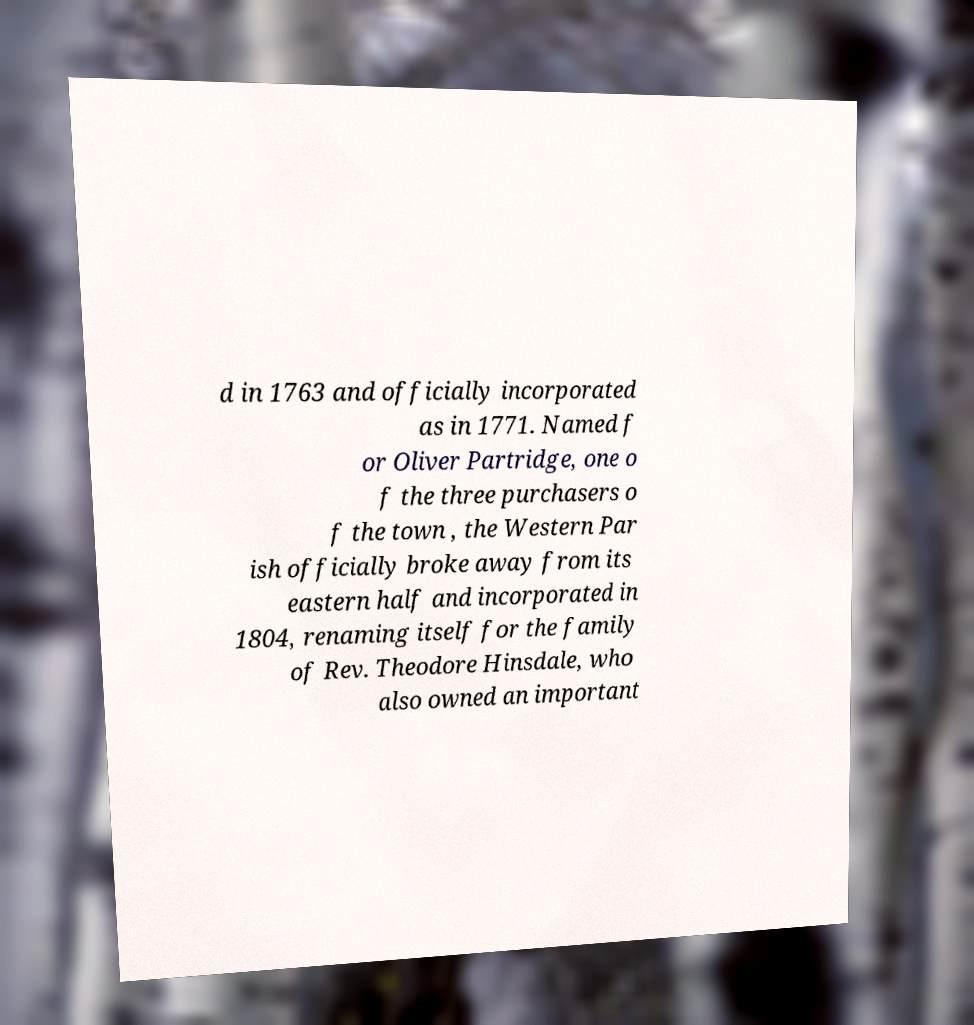Could you extract and type out the text from this image? d in 1763 and officially incorporated as in 1771. Named f or Oliver Partridge, one o f the three purchasers o f the town , the Western Par ish officially broke away from its eastern half and incorporated in 1804, renaming itself for the family of Rev. Theodore Hinsdale, who also owned an important 